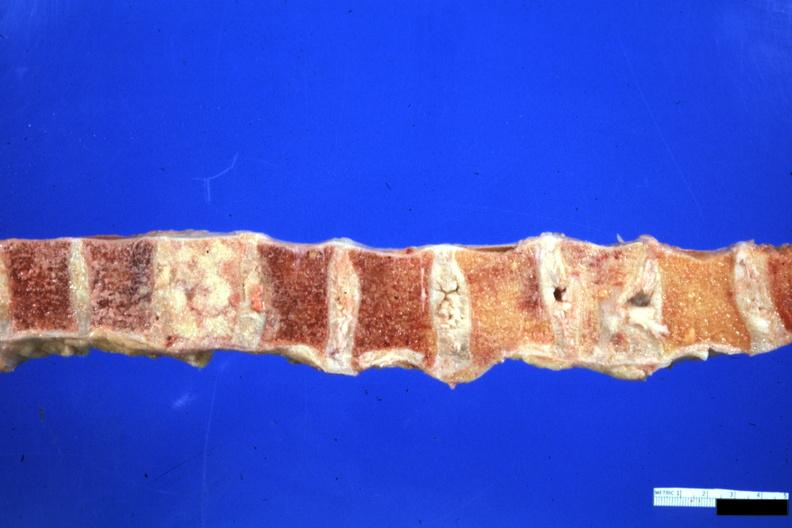what does this image show?
Answer the question using a single word or phrase. Vertebra column one collapsed vertebra and one filled with neoplasm looks like breast carcinoma but is an unclassified lymphoma 